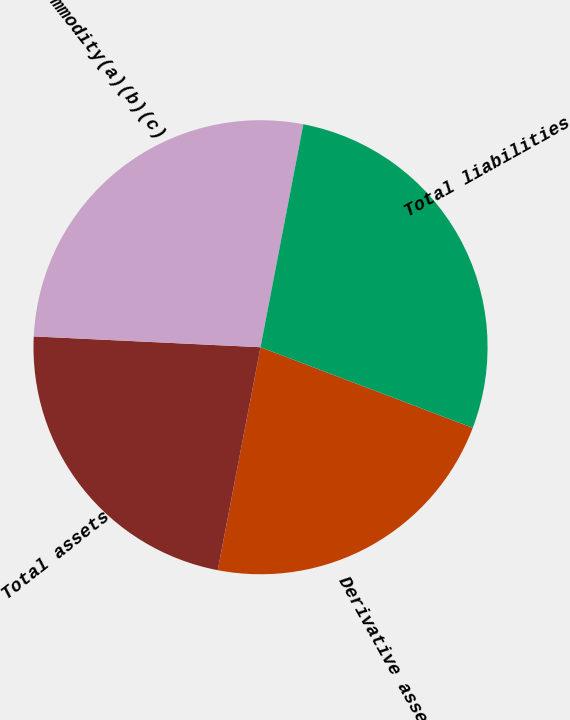Convert chart to OTSL. <chart><loc_0><loc_0><loc_500><loc_500><pie_chart><fcel>Derivative assets<fcel>Total assets<fcel>Commodity(a)(b)(c)<fcel>Total liabilities<nl><fcel>22.24%<fcel>22.74%<fcel>27.26%<fcel>27.76%<nl></chart> 